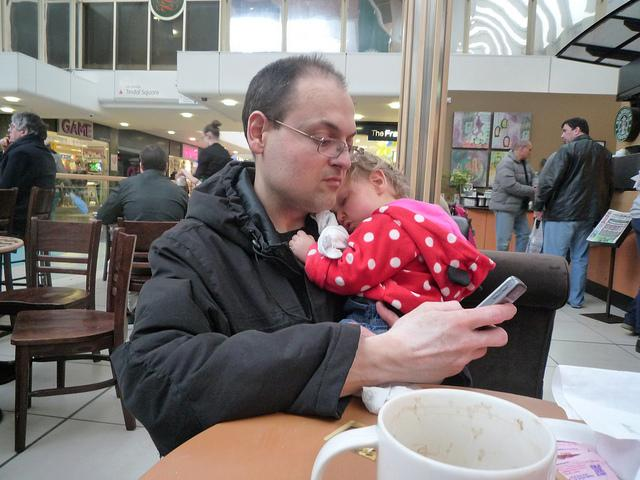Where is this man and child sitting? restaurant 